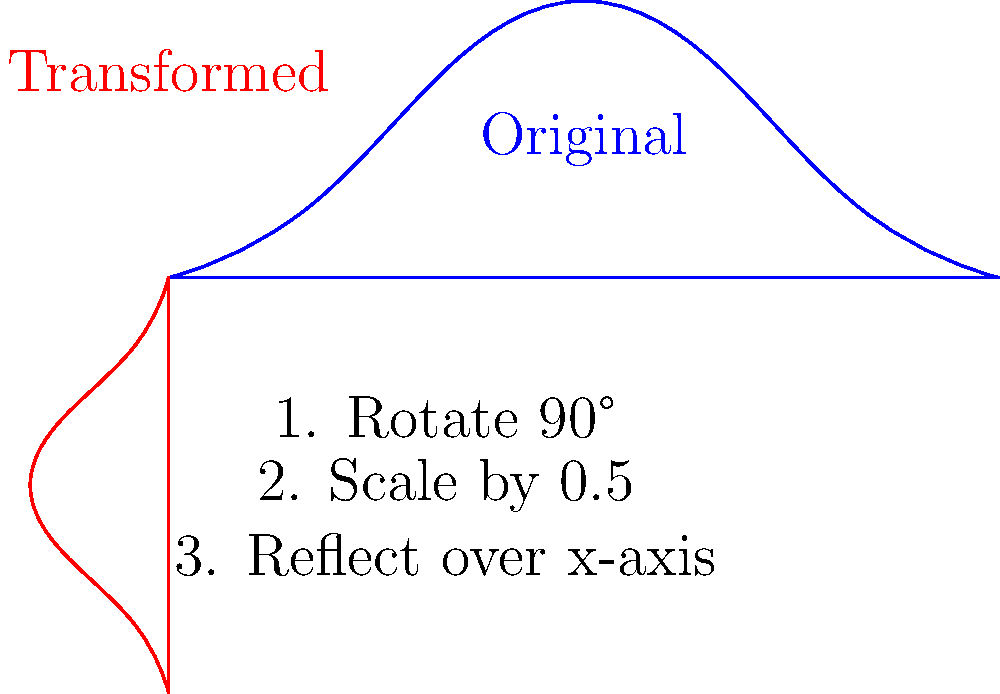In a tribute to the Master of Suspense, you've decided to transform the iconic silhouette of Alfred Hitchcock for your next lecture on Transformational Geometry. Starting with the original profile, you apply the following sequence of transformations:

1. Rotate 90° counterclockwise
2. Scale by a factor of 0.5
3. Reflect over the x-axis

What is the correct order of matrix multiplication to represent this composition of transformations? Express your answer using the notation $R_{90°}$ for rotation, $S_{0.5}$ for scaling, and $F_x$ for reflection over the x-axis. Let's approach this step-by-step, keeping in mind that in matrix multiplication for transformations, we apply the rightmost matrix first:

1. The first transformation applied is the 90° rotation, represented by $R_{90°}$.

2. The second transformation is scaling by 0.5, represented by $S_{0.5}$.

3. The final transformation is reflection over the x-axis, represented by $F_x$.

Since we apply these transformations in the order 1-2-3, but matrix multiplication works from right to left, we need to write them in the reverse order.

Therefore, the correct composition of transformations, when written as a product of matrices, is:

$$F_x \cdot S_{0.5} \cdot R_{90°}$$

This order ensures that when applied to a point or shape, the rotation happens first, then the scaling, and finally the reflection, just as described in the problem.
Answer: $F_x \cdot S_{0.5} \cdot R_{90°}$ 